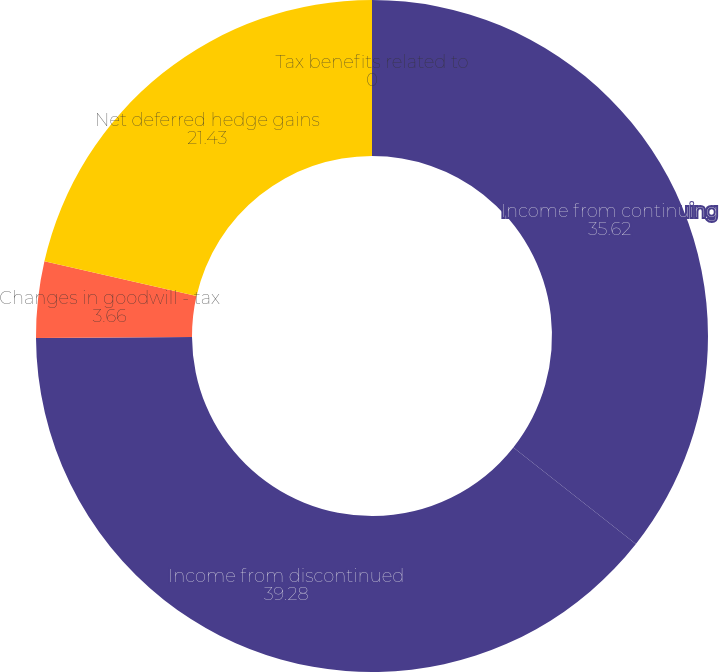Convert chart to OTSL. <chart><loc_0><loc_0><loc_500><loc_500><pie_chart><fcel>Income from continuing<fcel>Income from discontinued<fcel>Changes in goodwill - tax<fcel>Net deferred hedge gains<fcel>Tax benefits related to<nl><fcel>35.62%<fcel>39.28%<fcel>3.66%<fcel>21.43%<fcel>0.0%<nl></chart> 